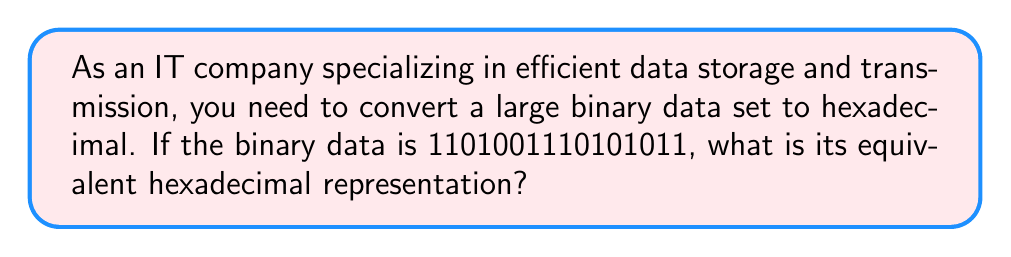What is the answer to this math problem? To convert binary to hexadecimal, we can follow these steps:

1. Group the binary digits into sets of 4, starting from the right:
   $$1101\space0011\space1010\space1011$$

2. Convert each group of 4 binary digits to its hexadecimal equivalent:

   For $1101$:
   $$1101_2 = (1 \times 2^3) + (1 \times 2^2) + (0 \times 2^1) + (1 \times 2^0) = 8 + 4 + 0 + 1 = 13_{10} = \text{D}_{16}$$

   For $0011$:
   $$0011_2 = (0 \times 2^3) + (0 \times 2^2) + (1 \times 2^1) + (1 \times 2^0) = 0 + 0 + 2 + 1 = 3_{10} = \text{3}_{16}$$

   For $1010$:
   $$1010_2 = (1 \times 2^3) + (0 \times 2^2) + (1 \times 2^1) + (0 \times 2^0) = 8 + 0 + 2 + 0 = 10_{10} = \text{A}_{16}$$

   For $1011$:
   $$1011_2 = (1 \times 2^3) + (0 \times 2^2) + (1 \times 2^1) + (1 \times 2^0) = 8 + 0 + 2 + 1 = 11_{10} = \text{B}_{16}$$

3. Combine the hexadecimal digits:
   $$1101001110101011_2 = \text{D3AB}_{16}$$

This conversion reduces the number of digits from 16 (in binary) to 4 (in hexadecimal), making it more efficient for storage and transmission in IT systems.
Answer: $\text{D3AB}_{16}$ 